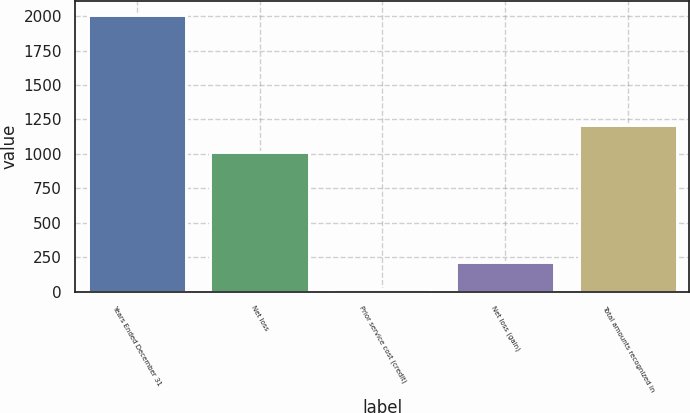Convert chart. <chart><loc_0><loc_0><loc_500><loc_500><bar_chart><fcel>Years Ended December 31<fcel>Net loss<fcel>Prior service cost (credit)<fcel>Net loss (gain)<fcel>Total amounts recognized in<nl><fcel>2011<fcel>1014<fcel>17<fcel>216.4<fcel>1213.4<nl></chart> 